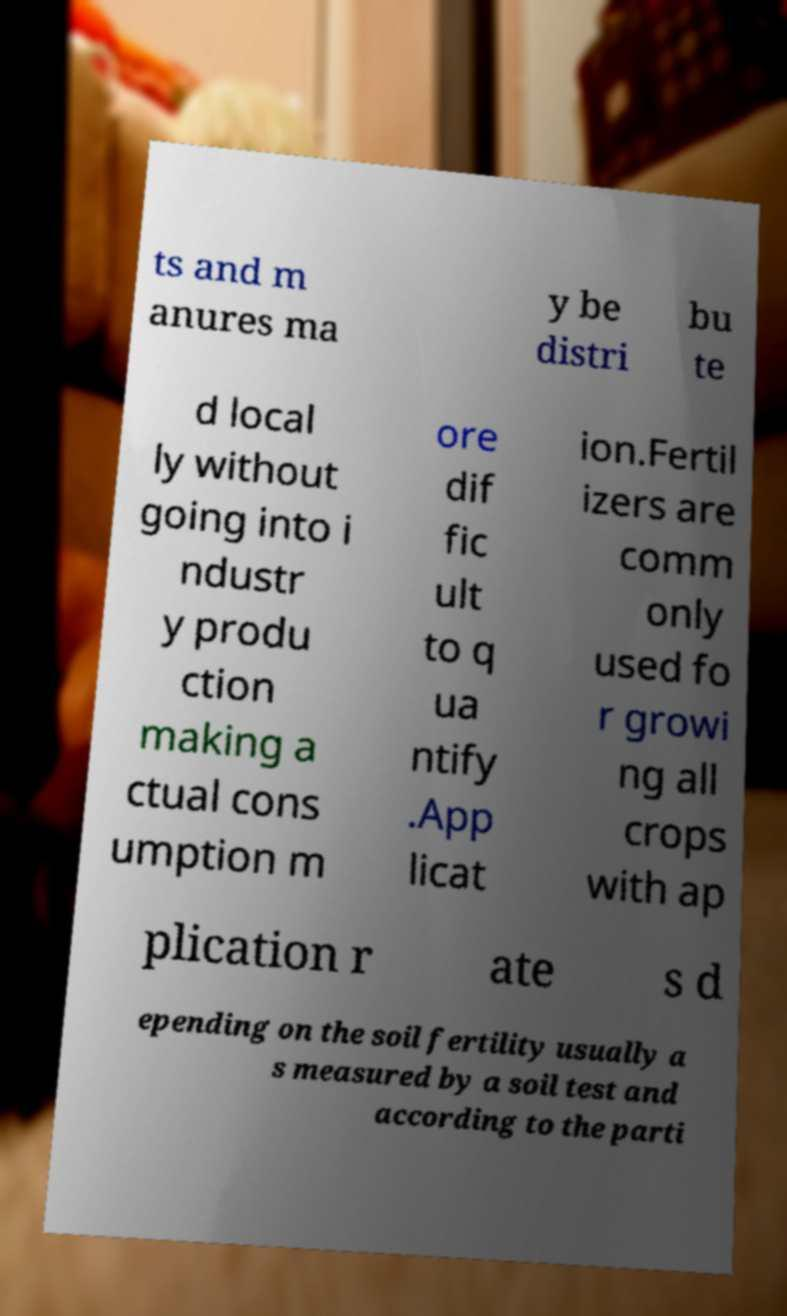Could you assist in decoding the text presented in this image and type it out clearly? ts and m anures ma y be distri bu te d local ly without going into i ndustr y produ ction making a ctual cons umption m ore dif fic ult to q ua ntify .App licat ion.Fertil izers are comm only used fo r growi ng all crops with ap plication r ate s d epending on the soil fertility usually a s measured by a soil test and according to the parti 